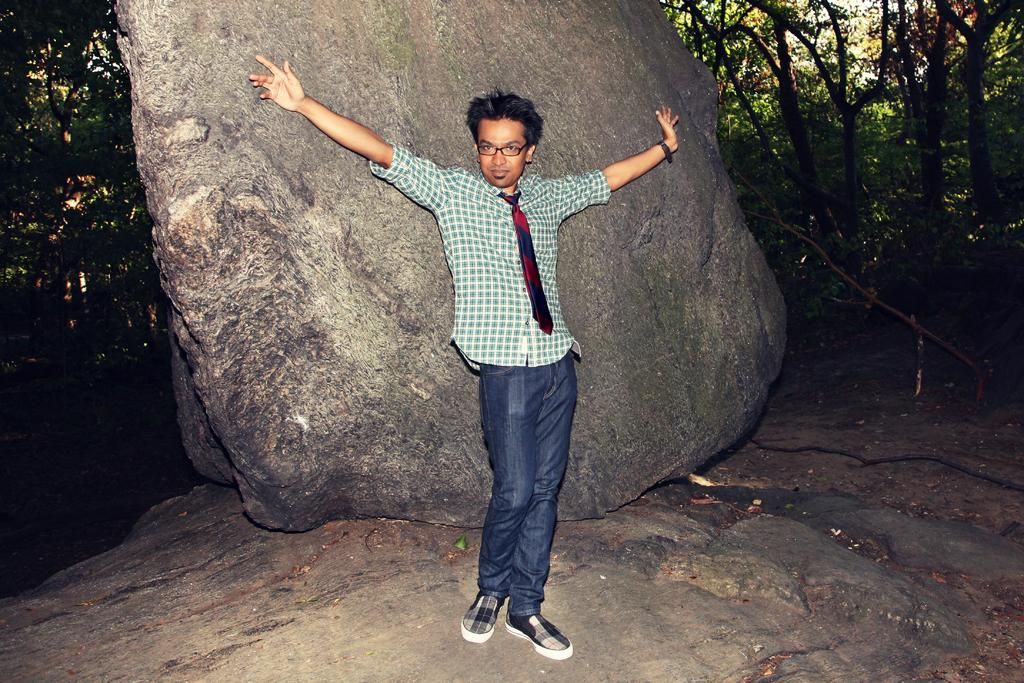What is the man doing in the image? The man is standing on a rock in the image. What is the man holding in his hand? The man is holding a pair of spectacles in his hand. What accessory is visible on the man's wrist? The man has a watch on his hand. What can be seen behind the man in the image? There is another rock behind the man. What type of vegetation is visible in the background of the image? Trees are present in the background of the image. What type of cheese is being used to care for the cabbage in the image? There is no cheese or cabbage present in the image; it features a man standing on a rock with a pair of spectacles and a watch. 